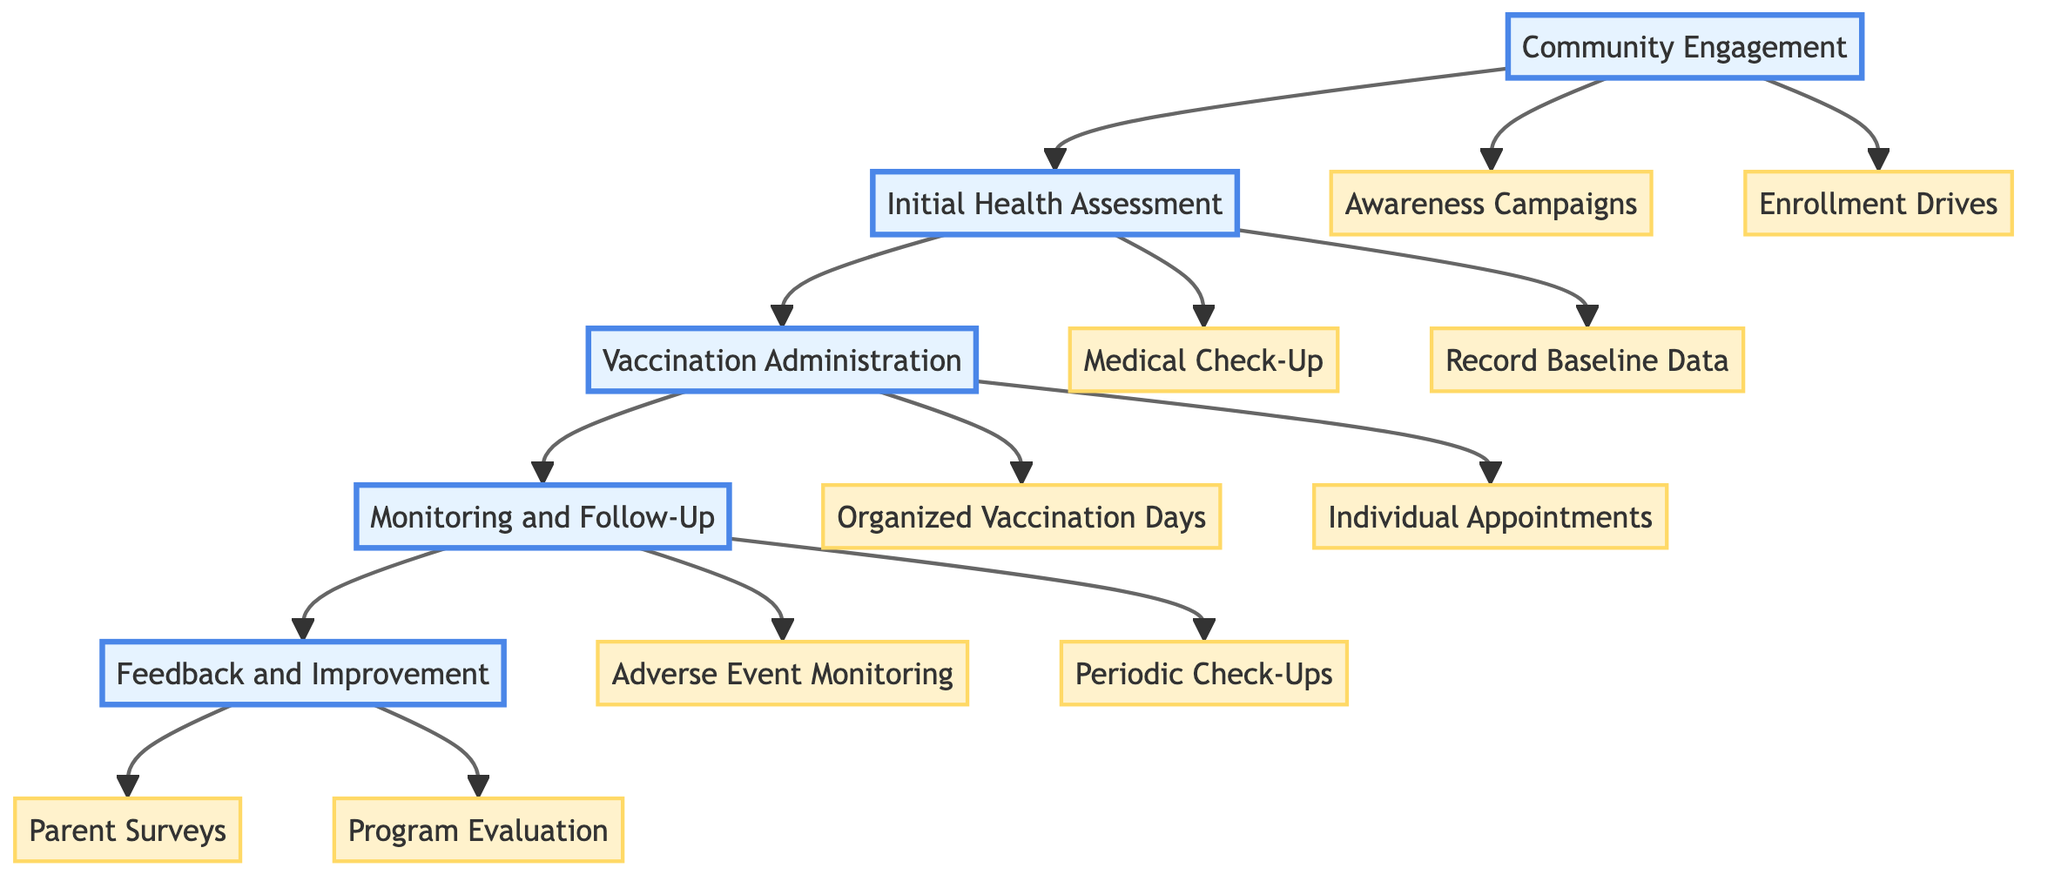What is the first step in the pathway? The diagram starts with "Community Engagement," which is the first step in the clinical pathway.
Answer: Community Engagement How many activities are listed under "Monitoring and Follow-Up"? There are two activities listed under "Monitoring and Follow-Up": "Adverse Event Monitoring" and "Periodic Check-Ups."
Answer: 2 Who are the key partners for "Awareness Campaigns"? The diagram indicates "Local NGOs" and "Community Leaders" as the key partners for the activity "Awareness Campaigns."
Answer: Local NGOs, Community Leaders What follows the "Vaccination Administration" step? The flow from "Vaccination Administration" leads directly to the "Monitoring and Follow-Up" step, indicating the sequence of actions.
Answer: Monitoring and Follow-Up What type of feedback is collected in the last step? In the final step "Feedback and Improvement," "Parent Surveys" are conducted to gather feedback from parents regarding the vaccination process.
Answer: Parent Surveys How many steps are there in total? The clinical pathway consists of five distinct steps: "Community Engagement," "Initial Health Assessment," "Vaccination Administration," "Monitoring and Follow-Up," and "Feedback and Improvement."
Answer: 5 What activity is performed during the "Initial Health Assessment"? The activities under "Initial Health Assessment" include "Medical Check-Up" and "Record Baseline Data," both of which are conducted to assess children's health.
Answer: Medical Check-Up, Record Baseline Data Which activity involves healthcare workers scheduling visits? "Individual Appointments" is the activity where flexible scheduling for parents and children is provided, involving healthcare workers in the process.
Answer: Individual Appointments What is the purpose of "Program Evaluation"? "Program Evaluation" aims to assess the overall impact and reach of the vaccination program, ensuring continuous improvement based on feedback.
Answer: Assess the overall impact and reach of the vaccination program 